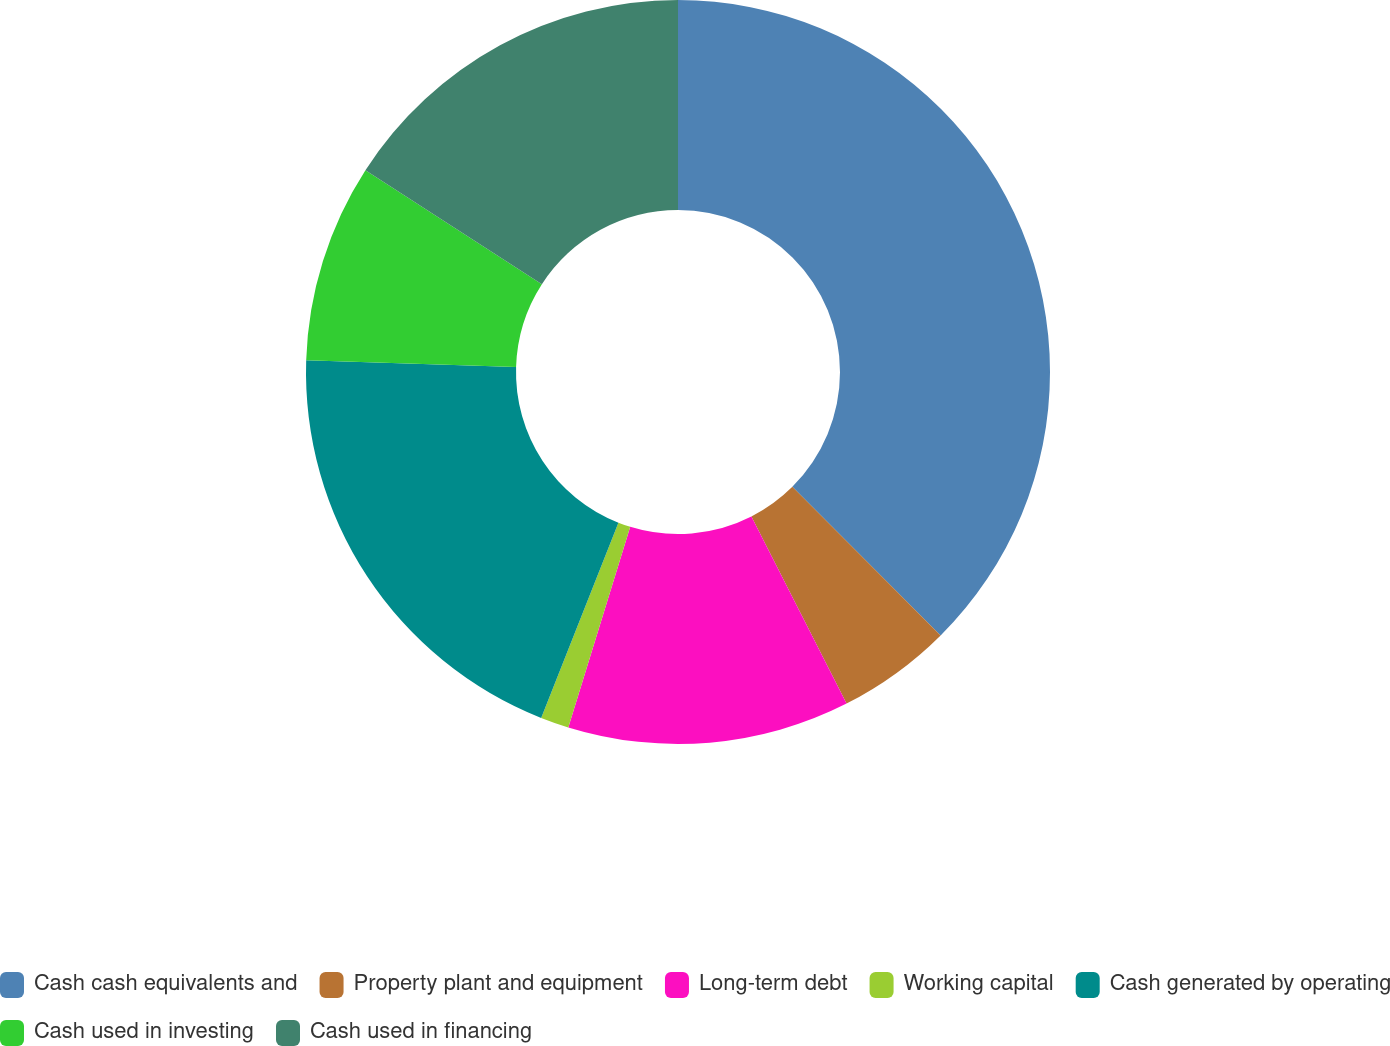<chart> <loc_0><loc_0><loc_500><loc_500><pie_chart><fcel>Cash cash equivalents and<fcel>Property plant and equipment<fcel>Long-term debt<fcel>Working capital<fcel>Cash generated by operating<fcel>Cash used in investing<fcel>Cash used in financing<nl><fcel>37.53%<fcel>4.99%<fcel>12.25%<fcel>1.23%<fcel>19.51%<fcel>8.62%<fcel>15.88%<nl></chart> 